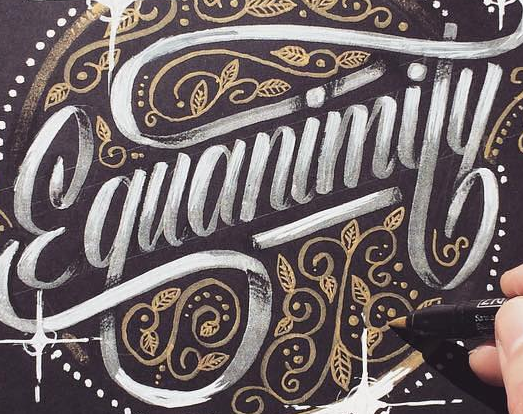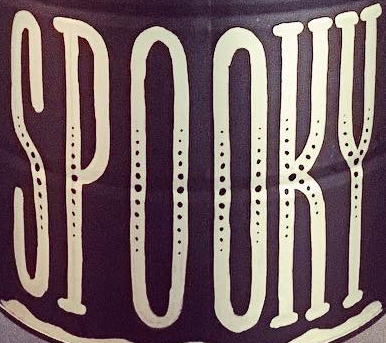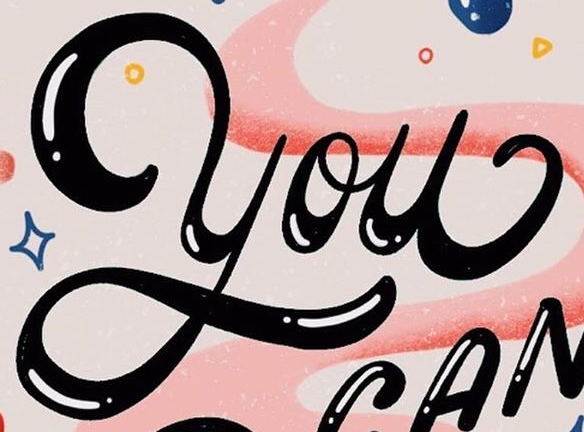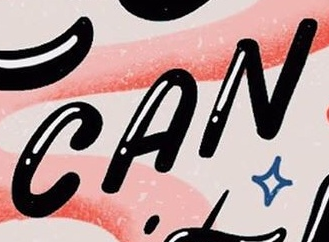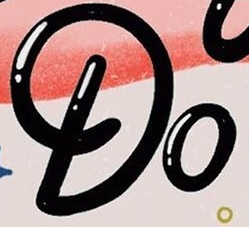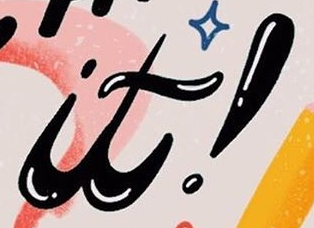Read the text from these images in sequence, separated by a semicolon. Ɛquanimity; SPOOKY; You; CAN; Do; it! 